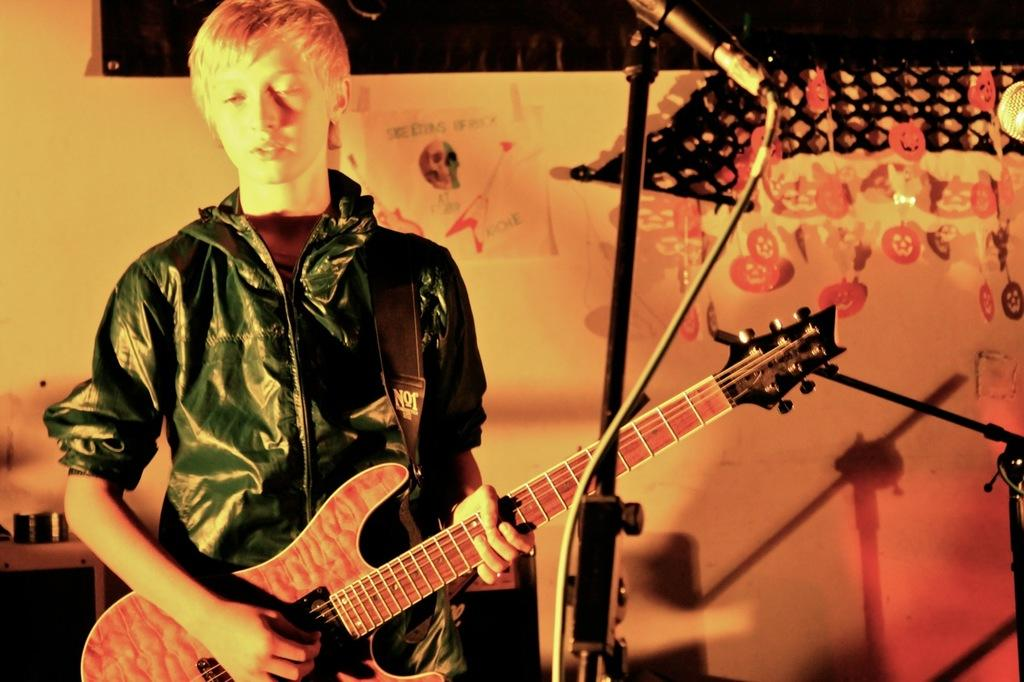What is the main subject of the image? There is a man in the image. What is the man doing in the image? The man is standing in the image. What object is the man holding in the image? The man is holding a guitar in his hand. What color is the jacket the man is wearing? The man is wearing a green jacket. What color is the wall in the background of the image? The wall in the background is yellow. Can you hear the bells ringing in the image? There are no bells present in the image, so it is not possible to hear them ringing. 